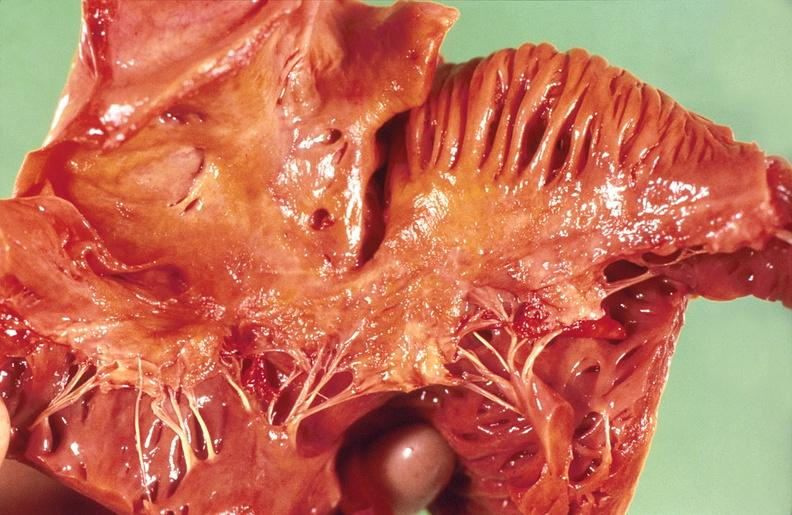does this image show amyloidosis?
Answer the question using a single word or phrase. Yes 